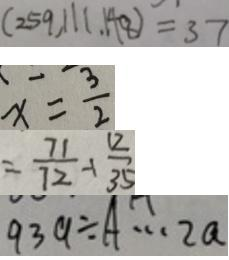<formula> <loc_0><loc_0><loc_500><loc_500>( 2 5 9 , 1 1 1 . 1 4 8 ) = 3 7 
 x = \frac { 3 } { 2 } 
 = \frac { 7 1 } { 7 2 } - 1 \frac { 1 2 } { 3 5 } 
 9 3 9 \div A \cdots 2 a</formula> 